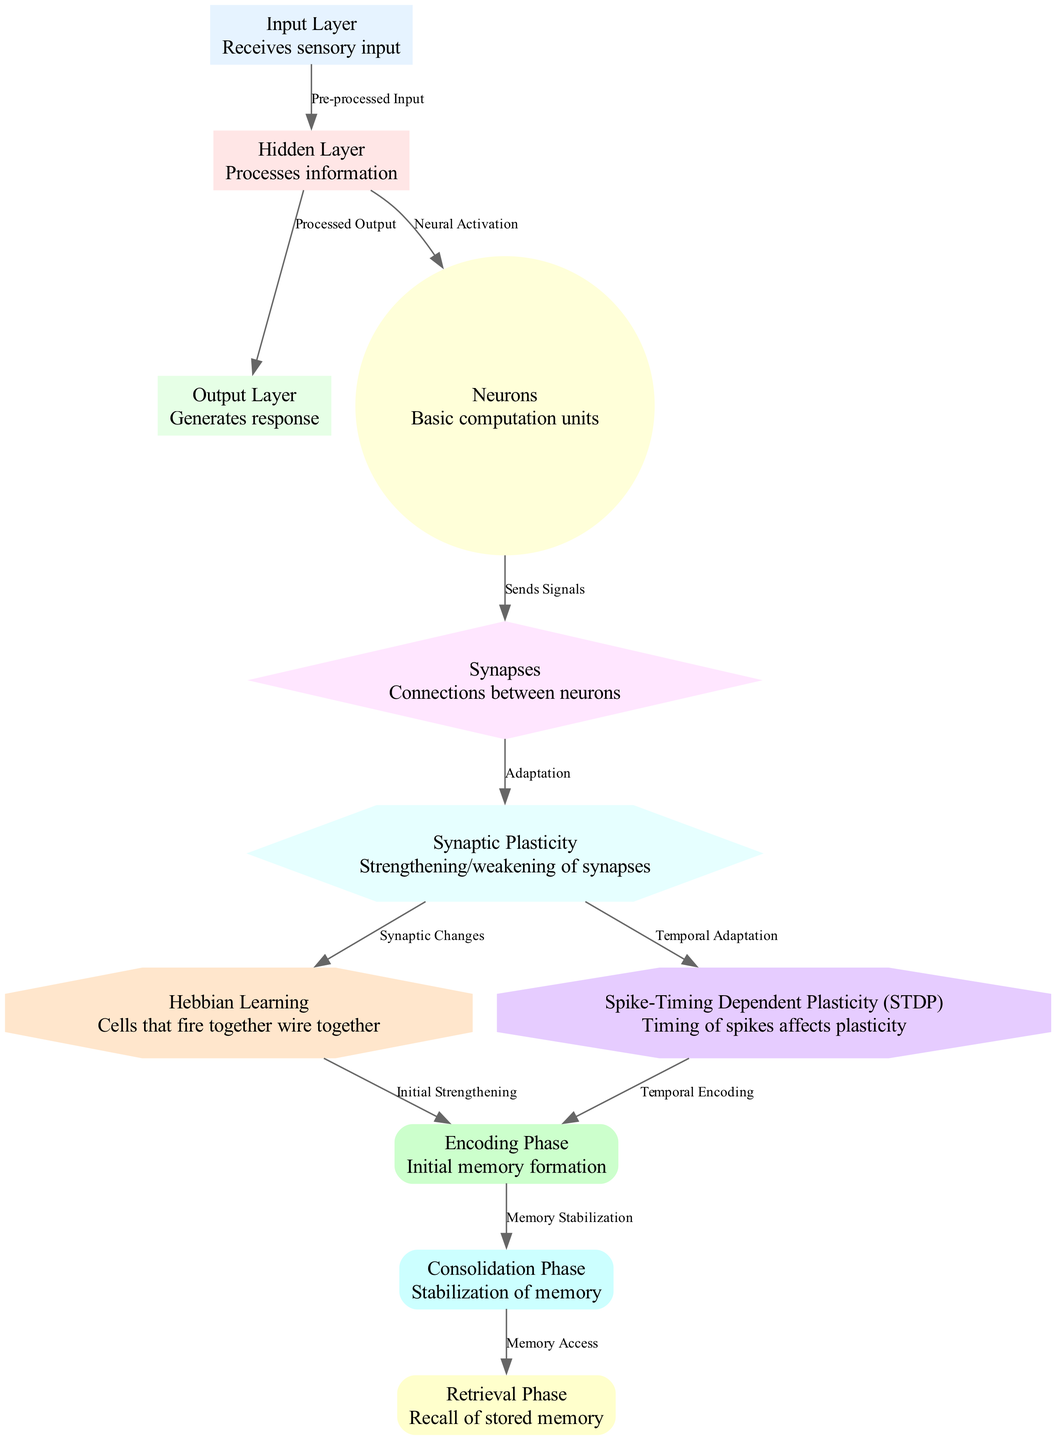What layer receives sensory input? The diagram shows that the "Input Layer" is where sensory input is received, as indicated by the node labeled "Input Layer" with the description "Receives sensory input."
Answer: Input Layer How many phases are involved in memory processing? Referring to the nodes labeled "Encoding Phase," "Consolidation Phase," and "Retrieval Phase," we see there are three distinct phases shown in the diagram.
Answer: Three What connects neurons to synaptic plasticity? The diagram depicts that "Synapses" connect "Neurons" to "Synaptic Plasticity," which is established through the edge labeled "Sends Signals" leading from "Neurons" to "Synapses."
Answer: Synapses Which learning type is linked to initial memory strengthening? By tracing the arrows, we can observe that "Hebbian Learning" is connected to "Encoding Phase" through the edge labeled "Initial Strengthening," indicating its role in memory formation.
Answer: Hebbian Learning What is the role of synaptic plasticity in the diagram? The diagram presents "Synaptic Plasticity" with an edge called "Adaptation" that receives input from "Synapses" and shows its role in enabling synaptic changes, thereby adapting synapses to strengthen or weaken.
Answer: Adaptation Which phase occurs after the consolidation phase? The diagram indicates that the "Retrieval Phase" comes after the "Consolidation Phase," as denoted by the edge that connects these two phases labeled "Memory Access."
Answer: Retrieval Phase What type of plasticity is affected by the timing of spikes? According to the diagram, "Spike-Timing Dependent Plasticity (STDP)" is the type associated with temporal aspects of synaptic changes, as shown by the edge connecting it to "Synaptic Plasticity" labeled "Temporal Adaptation."
Answer: Spike-Timing Dependent Plasticity Which layer produces the final response? Observing the diagram, the "Output Layer" is responsible for generating the response as indicated in the node labeled "Output Layer" which states "Generates response."
Answer: Output Layer What process stabilizes memory after encoding? The diagram indicates that the "Consolidation Phase" is responsible for stabilizing memory after the initial encoding, as shown by the edge labeled "Memory Stabilization" linking "Encoding Phase" to "Consolidation Phase."
Answer: Consolidation Phase 